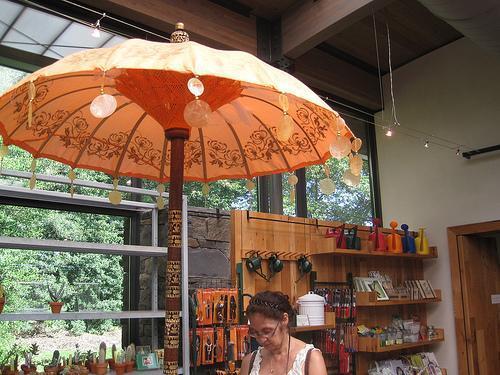How many people are shown?
Give a very brief answer. 1. How many watering cans are there?
Give a very brief answer. 6. 